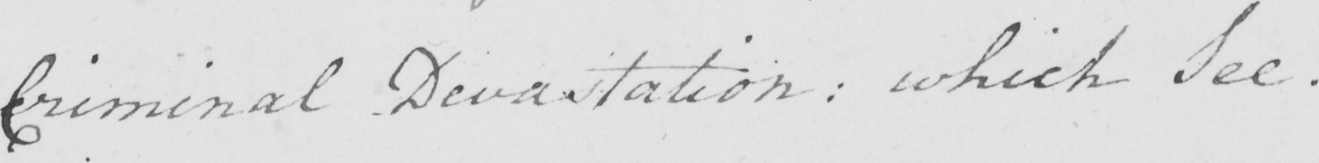Transcribe the text shown in this historical manuscript line. Criminal Devastation :  which See . 